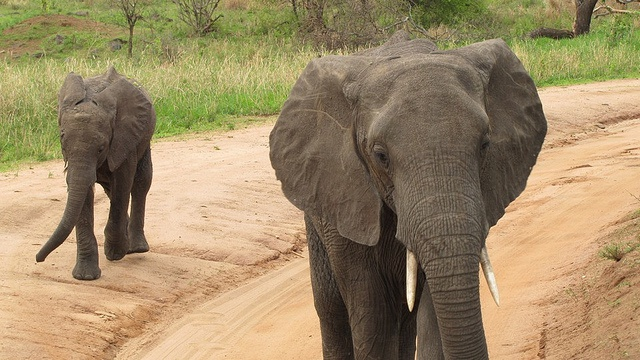Describe the objects in this image and their specific colors. I can see elephant in olive, gray, and black tones and elephant in olive, gray, black, and maroon tones in this image. 